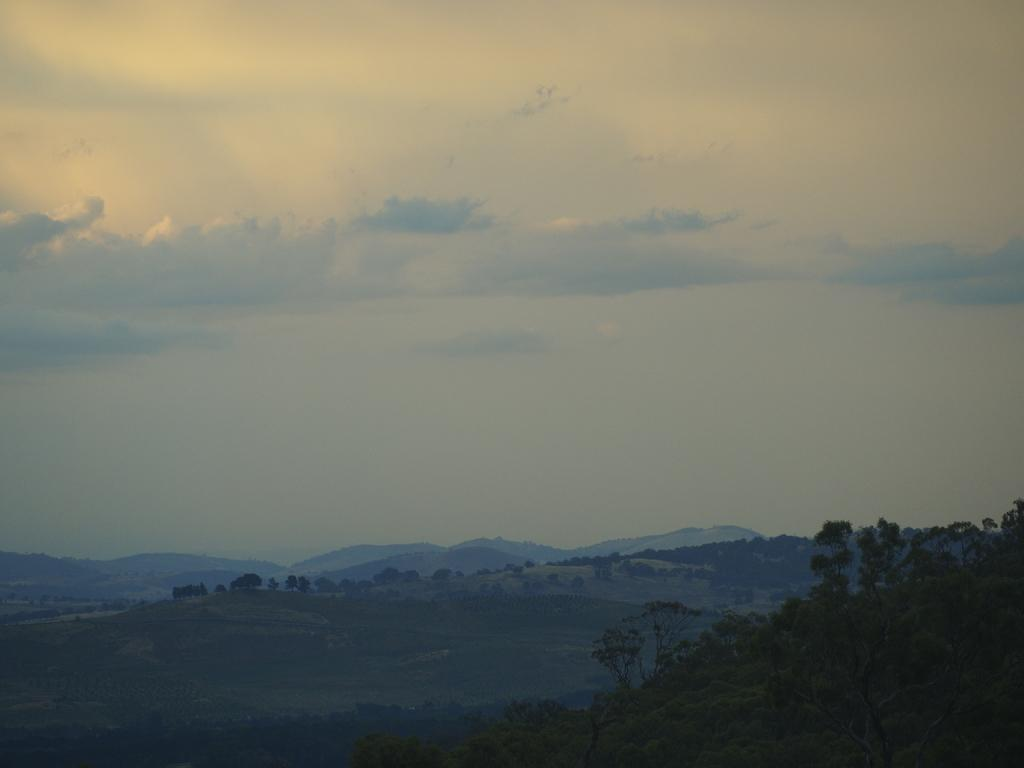What type of environment is depicted in the image? The image is full of greenery, which suggests a natural environment. What specific types of vegetation can be seen in the image? There are trees and grass in the image. What geographical features are present in the image? There are mountains in the image. What can be seen in the sky in the image? There are clouds in the sky in the image. What type of pickle is being used as an apparatus in the image? There is no pickle or apparatus present in the image; it features a natural environment with greenery, trees, grass, mountains, and clouds. 